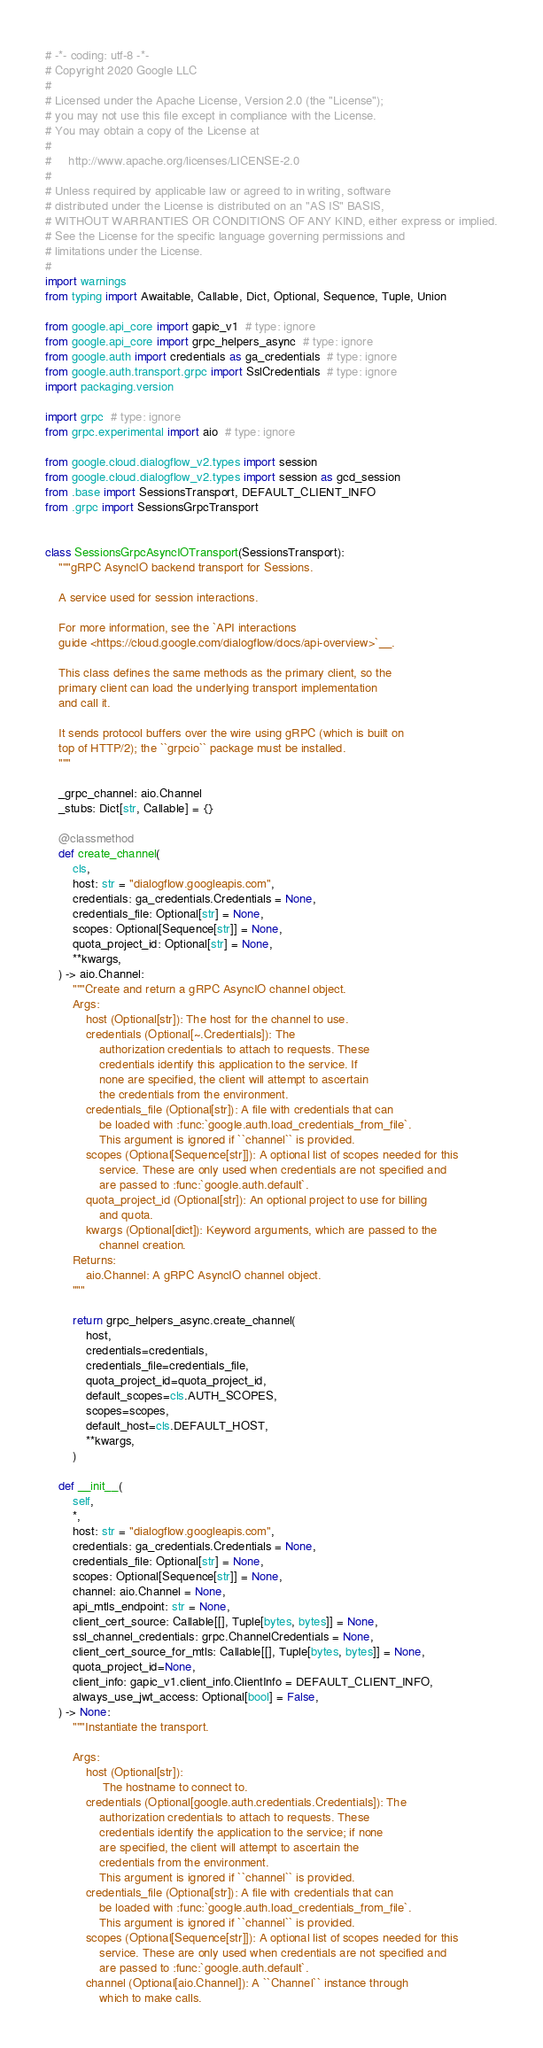<code> <loc_0><loc_0><loc_500><loc_500><_Python_># -*- coding: utf-8 -*-
# Copyright 2020 Google LLC
#
# Licensed under the Apache License, Version 2.0 (the "License");
# you may not use this file except in compliance with the License.
# You may obtain a copy of the License at
#
#     http://www.apache.org/licenses/LICENSE-2.0
#
# Unless required by applicable law or agreed to in writing, software
# distributed under the License is distributed on an "AS IS" BASIS,
# WITHOUT WARRANTIES OR CONDITIONS OF ANY KIND, either express or implied.
# See the License for the specific language governing permissions and
# limitations under the License.
#
import warnings
from typing import Awaitable, Callable, Dict, Optional, Sequence, Tuple, Union

from google.api_core import gapic_v1  # type: ignore
from google.api_core import grpc_helpers_async  # type: ignore
from google.auth import credentials as ga_credentials  # type: ignore
from google.auth.transport.grpc import SslCredentials  # type: ignore
import packaging.version

import grpc  # type: ignore
from grpc.experimental import aio  # type: ignore

from google.cloud.dialogflow_v2.types import session
from google.cloud.dialogflow_v2.types import session as gcd_session
from .base import SessionsTransport, DEFAULT_CLIENT_INFO
from .grpc import SessionsGrpcTransport


class SessionsGrpcAsyncIOTransport(SessionsTransport):
    """gRPC AsyncIO backend transport for Sessions.

    A service used for session interactions.

    For more information, see the `API interactions
    guide <https://cloud.google.com/dialogflow/docs/api-overview>`__.

    This class defines the same methods as the primary client, so the
    primary client can load the underlying transport implementation
    and call it.

    It sends protocol buffers over the wire using gRPC (which is built on
    top of HTTP/2); the ``grpcio`` package must be installed.
    """

    _grpc_channel: aio.Channel
    _stubs: Dict[str, Callable] = {}

    @classmethod
    def create_channel(
        cls,
        host: str = "dialogflow.googleapis.com",
        credentials: ga_credentials.Credentials = None,
        credentials_file: Optional[str] = None,
        scopes: Optional[Sequence[str]] = None,
        quota_project_id: Optional[str] = None,
        **kwargs,
    ) -> aio.Channel:
        """Create and return a gRPC AsyncIO channel object.
        Args:
            host (Optional[str]): The host for the channel to use.
            credentials (Optional[~.Credentials]): The
                authorization credentials to attach to requests. These
                credentials identify this application to the service. If
                none are specified, the client will attempt to ascertain
                the credentials from the environment.
            credentials_file (Optional[str]): A file with credentials that can
                be loaded with :func:`google.auth.load_credentials_from_file`.
                This argument is ignored if ``channel`` is provided.
            scopes (Optional[Sequence[str]]): A optional list of scopes needed for this
                service. These are only used when credentials are not specified and
                are passed to :func:`google.auth.default`.
            quota_project_id (Optional[str]): An optional project to use for billing
                and quota.
            kwargs (Optional[dict]): Keyword arguments, which are passed to the
                channel creation.
        Returns:
            aio.Channel: A gRPC AsyncIO channel object.
        """

        return grpc_helpers_async.create_channel(
            host,
            credentials=credentials,
            credentials_file=credentials_file,
            quota_project_id=quota_project_id,
            default_scopes=cls.AUTH_SCOPES,
            scopes=scopes,
            default_host=cls.DEFAULT_HOST,
            **kwargs,
        )

    def __init__(
        self,
        *,
        host: str = "dialogflow.googleapis.com",
        credentials: ga_credentials.Credentials = None,
        credentials_file: Optional[str] = None,
        scopes: Optional[Sequence[str]] = None,
        channel: aio.Channel = None,
        api_mtls_endpoint: str = None,
        client_cert_source: Callable[[], Tuple[bytes, bytes]] = None,
        ssl_channel_credentials: grpc.ChannelCredentials = None,
        client_cert_source_for_mtls: Callable[[], Tuple[bytes, bytes]] = None,
        quota_project_id=None,
        client_info: gapic_v1.client_info.ClientInfo = DEFAULT_CLIENT_INFO,
        always_use_jwt_access: Optional[bool] = False,
    ) -> None:
        """Instantiate the transport.

        Args:
            host (Optional[str]):
                 The hostname to connect to.
            credentials (Optional[google.auth.credentials.Credentials]): The
                authorization credentials to attach to requests. These
                credentials identify the application to the service; if none
                are specified, the client will attempt to ascertain the
                credentials from the environment.
                This argument is ignored if ``channel`` is provided.
            credentials_file (Optional[str]): A file with credentials that can
                be loaded with :func:`google.auth.load_credentials_from_file`.
                This argument is ignored if ``channel`` is provided.
            scopes (Optional[Sequence[str]]): A optional list of scopes needed for this
                service. These are only used when credentials are not specified and
                are passed to :func:`google.auth.default`.
            channel (Optional[aio.Channel]): A ``Channel`` instance through
                which to make calls.</code> 